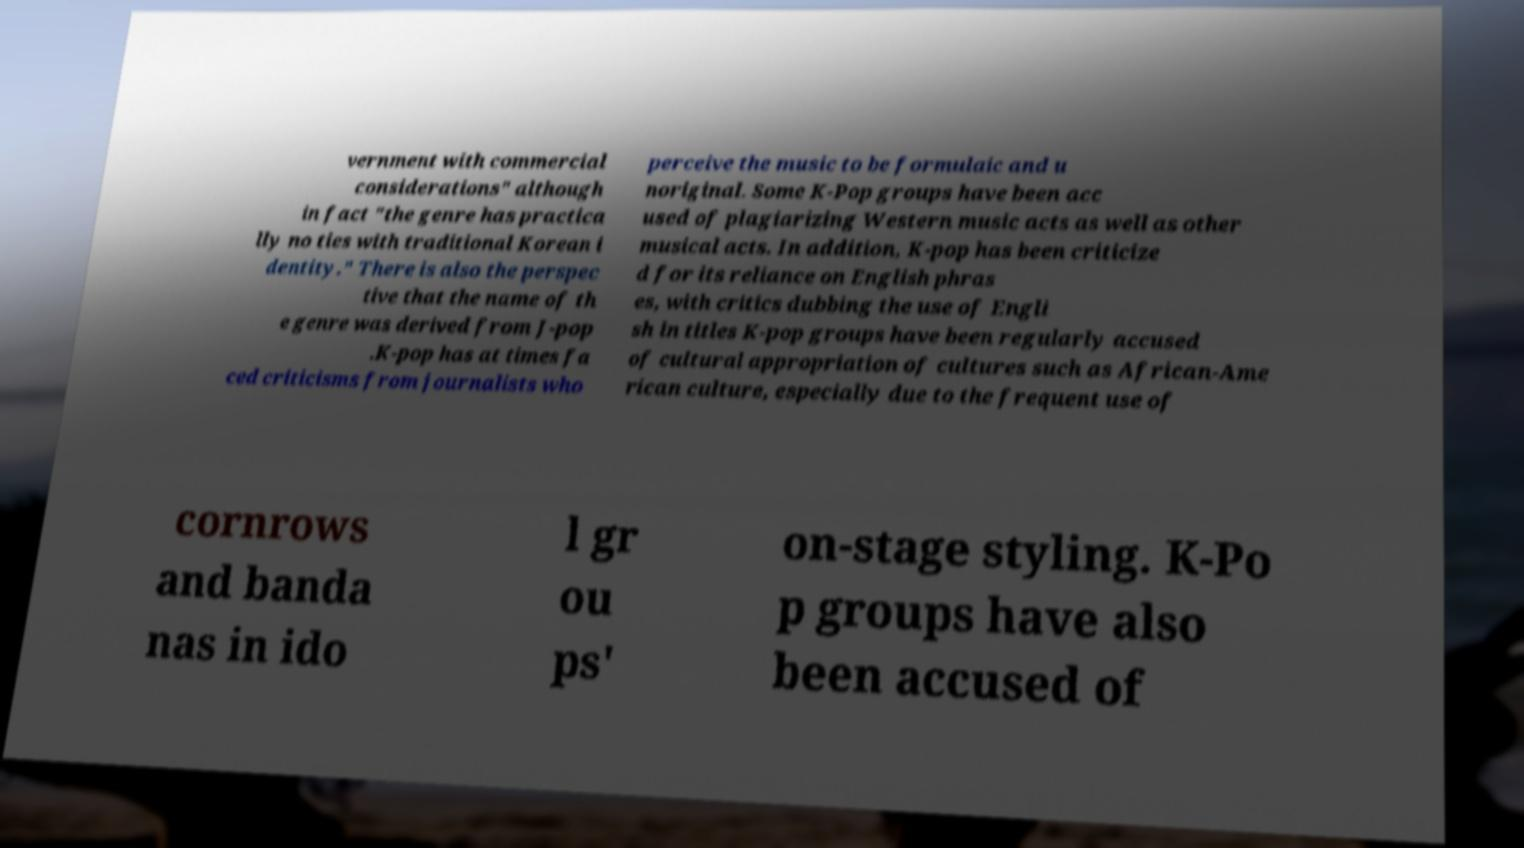Please identify and transcribe the text found in this image. vernment with commercial considerations" although in fact "the genre has practica lly no ties with traditional Korean i dentity." There is also the perspec tive that the name of th e genre was derived from J-pop .K-pop has at times fa ced criticisms from journalists who perceive the music to be formulaic and u noriginal. Some K-Pop groups have been acc used of plagiarizing Western music acts as well as other musical acts. In addition, K-pop has been criticize d for its reliance on English phras es, with critics dubbing the use of Engli sh in titles K-pop groups have been regularly accused of cultural appropriation of cultures such as African-Ame rican culture, especially due to the frequent use of cornrows and banda nas in ido l gr ou ps' on-stage styling. K-Po p groups have also been accused of 